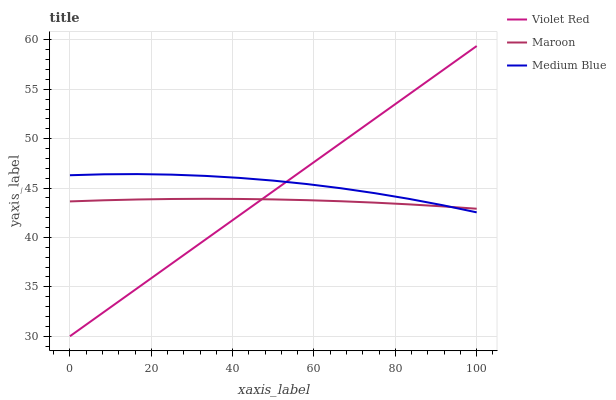Does Maroon have the minimum area under the curve?
Answer yes or no. Yes. Does Medium Blue have the maximum area under the curve?
Answer yes or no. Yes. Does Medium Blue have the minimum area under the curve?
Answer yes or no. No. Does Maroon have the maximum area under the curve?
Answer yes or no. No. Is Violet Red the smoothest?
Answer yes or no. Yes. Is Medium Blue the roughest?
Answer yes or no. Yes. Is Maroon the smoothest?
Answer yes or no. No. Is Maroon the roughest?
Answer yes or no. No. Does Violet Red have the lowest value?
Answer yes or no. Yes. Does Medium Blue have the lowest value?
Answer yes or no. No. Does Violet Red have the highest value?
Answer yes or no. Yes. Does Medium Blue have the highest value?
Answer yes or no. No. Does Violet Red intersect Medium Blue?
Answer yes or no. Yes. Is Violet Red less than Medium Blue?
Answer yes or no. No. Is Violet Red greater than Medium Blue?
Answer yes or no. No. 